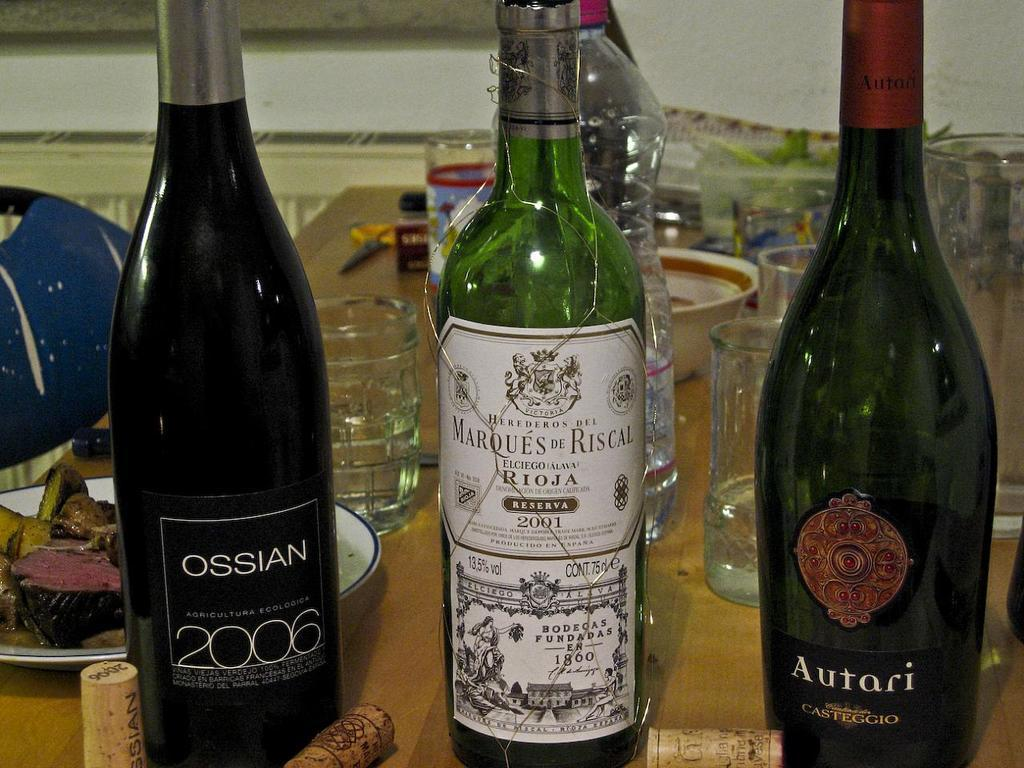<image>
Present a compact description of the photo's key features. A bottle of Ossian wine that was made in 2006. 